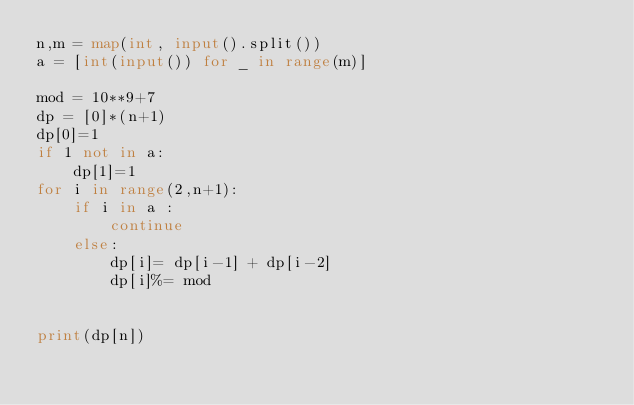<code> <loc_0><loc_0><loc_500><loc_500><_Python_>n,m = map(int, input().split())
a = [int(input()) for _ in range(m)]

mod = 10**9+7
dp = [0]*(n+1)
dp[0]=1
if 1 not in a:
    dp[1]=1
for i in range(2,n+1):
    if i in a :
        continue
    else:
        dp[i]= dp[i-1] + dp[i-2]
        dp[i]%= mod


print(dp[n])</code> 